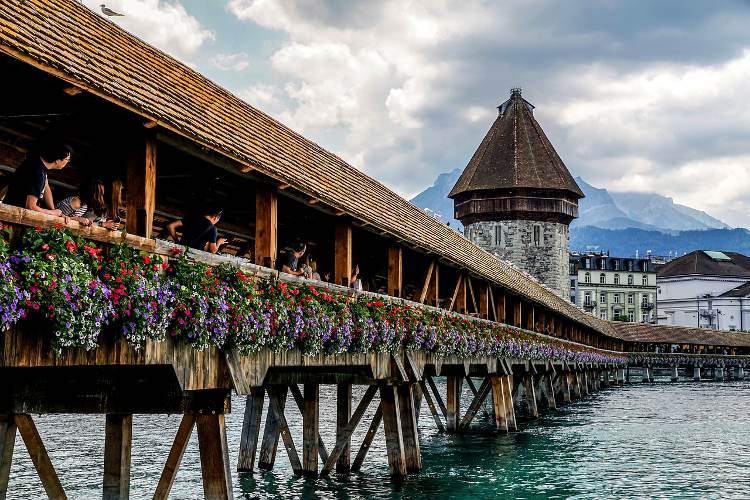Describe a scenario where a photographer might capture an award-winning photo on this bridge. A photographer might capture an award-winning photo on the Chapel Bridge at dawn. The scene is serene as the first light of day casts a golden glow over the wooden structure. The flowers lining the bridge sparkle with dew, their colors intensified by the soft morning light. A solitary figure stands at the center of the bridge, gazing out towards the mountains, their reflection mirrored in the still waters below. The sky is a palette of pastel hues, with hints of purple, pink, and orange blending seamlessly, and a light mist rises from the river, adding an ethereal quality to the scene. The composition balances the stately Water Tower, the vibrant flowers, the tranquil river, and the majestic Alps in the background, encapsulating the tranquil beauty and timelessness of this iconic location. Capturing this moment where nature and human presence harmoniously blend could be the defining shot of a photographer's career.  What would it be like to see this bridge during a thunderstorm? Viewing the Chapel Bridge during a thunderstorm would be an awe-inspiring experience. Dark, heavy clouds would loom overhead, casting a dramatic shadow over the structure. Flashes of lightning would intermittently illuminate the wooden beams and the stone tower, creating a striking contrast against the storm's ominous backdrop. The vibrant flowers might sway violently with the gusts of wind, their colors stark against the dark atmosphere. Raindrops would pelt the roof and the river below, forming ripples that dance wildly with each downpour. The normally calm Reuss River might swell and churn, reflecting the tempest above. The bridge, steadfast and enduring throughout centuries, would stand as a symbol of resilience amidst the roaring elements, its rustic charm highlighted against nature's raw power. 